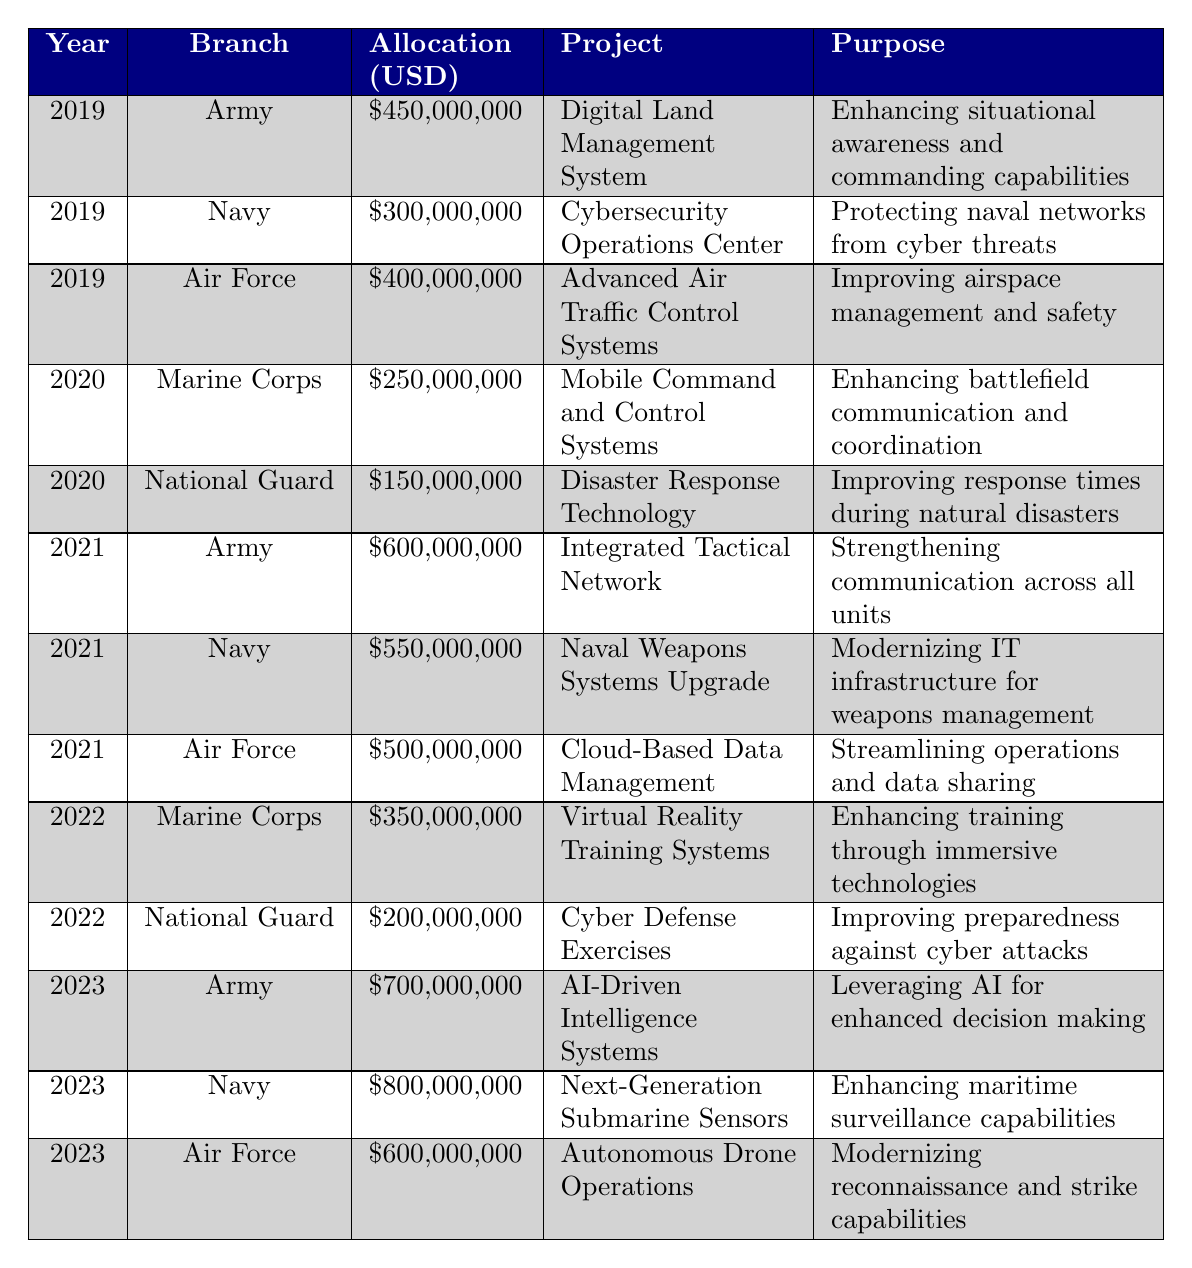What was the total budget allocated for military IT infrastructure in 2021? To find the total budget for 2021, we need to sum the allocation amounts for each branch in that year: Army ($600,000,000) + Navy ($550,000,000) + Air Force ($500,000,000) = $1,650,000,000.
Answer: $1,650,000,000 Which military branch received the highest allocation in 2023? In 2023, the allocations were: Army ($700,000,000), Navy ($800,000,000), Air Force ($600,000,000). Comparing these amounts, the Navy received the highest amount at $800,000,000.
Answer: Navy What is the total budget allocated to the Marine Corps over the past five years? The Marine Corps received allocations of: 2019 ($0), 2020 ($250,000,000), 2021 ($0), 2022 ($350,000,000), 2023 ($0). Adding these amounts gives $250,000,000 + $350,000,000 = $600,000,000.
Answer: $600,000,000 Did the National Guard have a higher allocation in 2022 compared to 2020? In 2020, the National Guard received $150,000,000, and in 2022, they received $200,000,000. Since $200,000,000 is greater than $150,000,000, the statement is true.
Answer: Yes What was the average allocation amount for the Air Force over the 5-year period? The allocations for the Air Force were: 2019 ($400,000,000), 2021 ($500,000,000), 2022 ($0), 2023 ($600,000,000). There was no allocation in 2020. Summing these, we get $400,000,000 + $500,000,000 + $0 + $600,000,000 = $1,500,000,000. There are 4 data points (not counting 2020). Thus, the average is $1,500,000,000 / 4 = $375,000,000.
Answer: $375,000,000 What is the purpose of the project receiving the largest budget allocation in 2023? The largest allocation in 2023 was for the Navy's Next-Generation Submarine Sensors, which has the purpose of enhancing maritime surveillance capabilities.
Answer: Enhancing maritime surveillance capabilities Which year saw the lowest total allocation across all branches? To determine this, we need to calculate total allocations for each year: 
2019 - $450,000,000 + $300,000,000 + $400,000,000 = $1,150,000,000; 
2020 - $250,000,000 + $150,000,000 = $400,000,000; 
2021 - $600,000,000 + $550,000,000 + $500,000,000 = $1,650,000,000; 
2022 - $350,000,000 + $200,000,000 = $550,000,000; 
2023 - $700,000,000 + $800,000,000 + $600,000,000 = $2,100,000,000. 
The smallest total is for 2020 with $400,000,000.
Answer: 2020 Which project aimed at enhancing situational awareness and commanding capabilities? The project called "Digital Land Management System," funded in 2019, aimed at enhancing situational awareness and commanding capabilities.
Answer: Digital Land Management System Did the Army's allocation increase, decrease, or remain the same from 2021 to 2023? In 2021, the Army's allocation was $600,000,000, and in 2023 it increased to $700,000,000. Since $700,000,000 is greater than $600,000,000, the allocation increased.
Answer: Increased Which branch had a project focused on disaster response technology, and what was the budget allocation? The National Guard had a project called "Disaster Response Technology" in 2020 with a budget allocation of $150,000,000.
Answer: National Guard, $150,000,000 